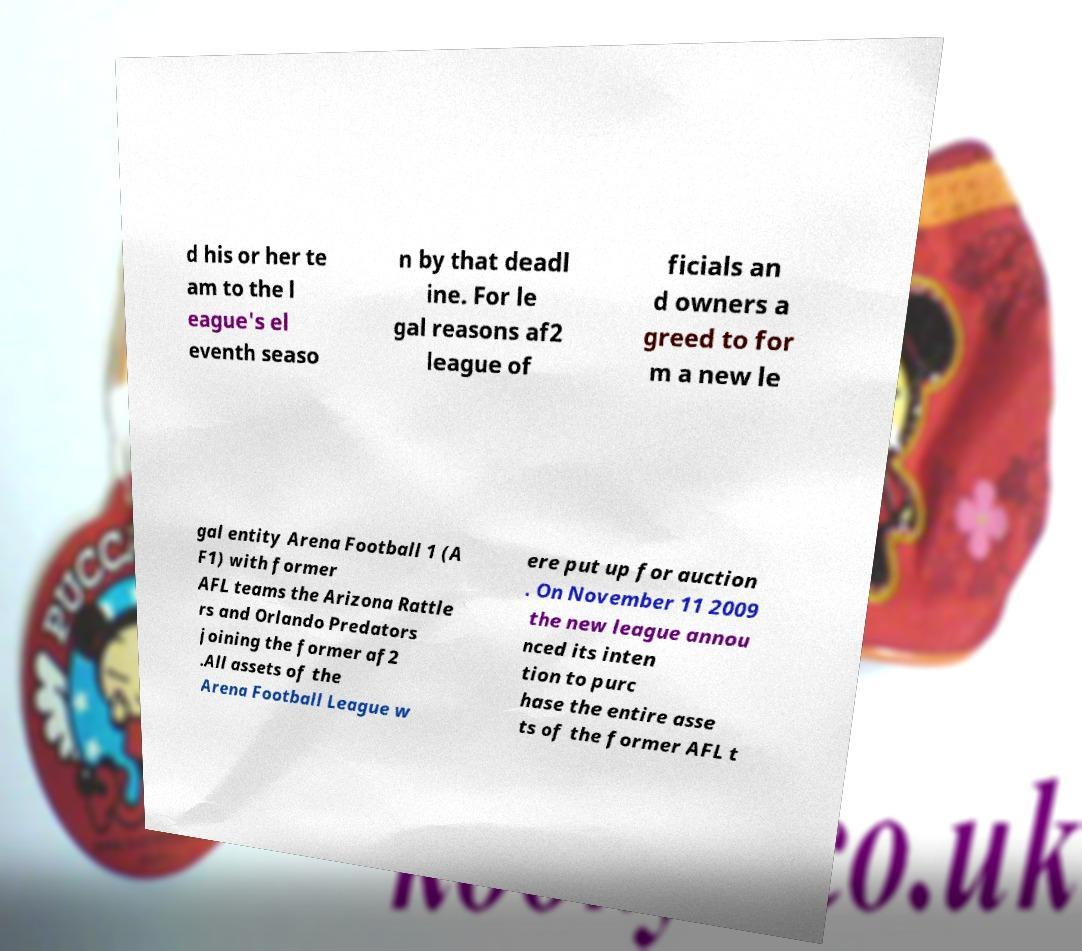Could you assist in decoding the text presented in this image and type it out clearly? d his or her te am to the l eague's el eventh seaso n by that deadl ine. For le gal reasons af2 league of ficials an d owners a greed to for m a new le gal entity Arena Football 1 (A F1) with former AFL teams the Arizona Rattle rs and Orlando Predators joining the former af2 .All assets of the Arena Football League w ere put up for auction . On November 11 2009 the new league annou nced its inten tion to purc hase the entire asse ts of the former AFL t 